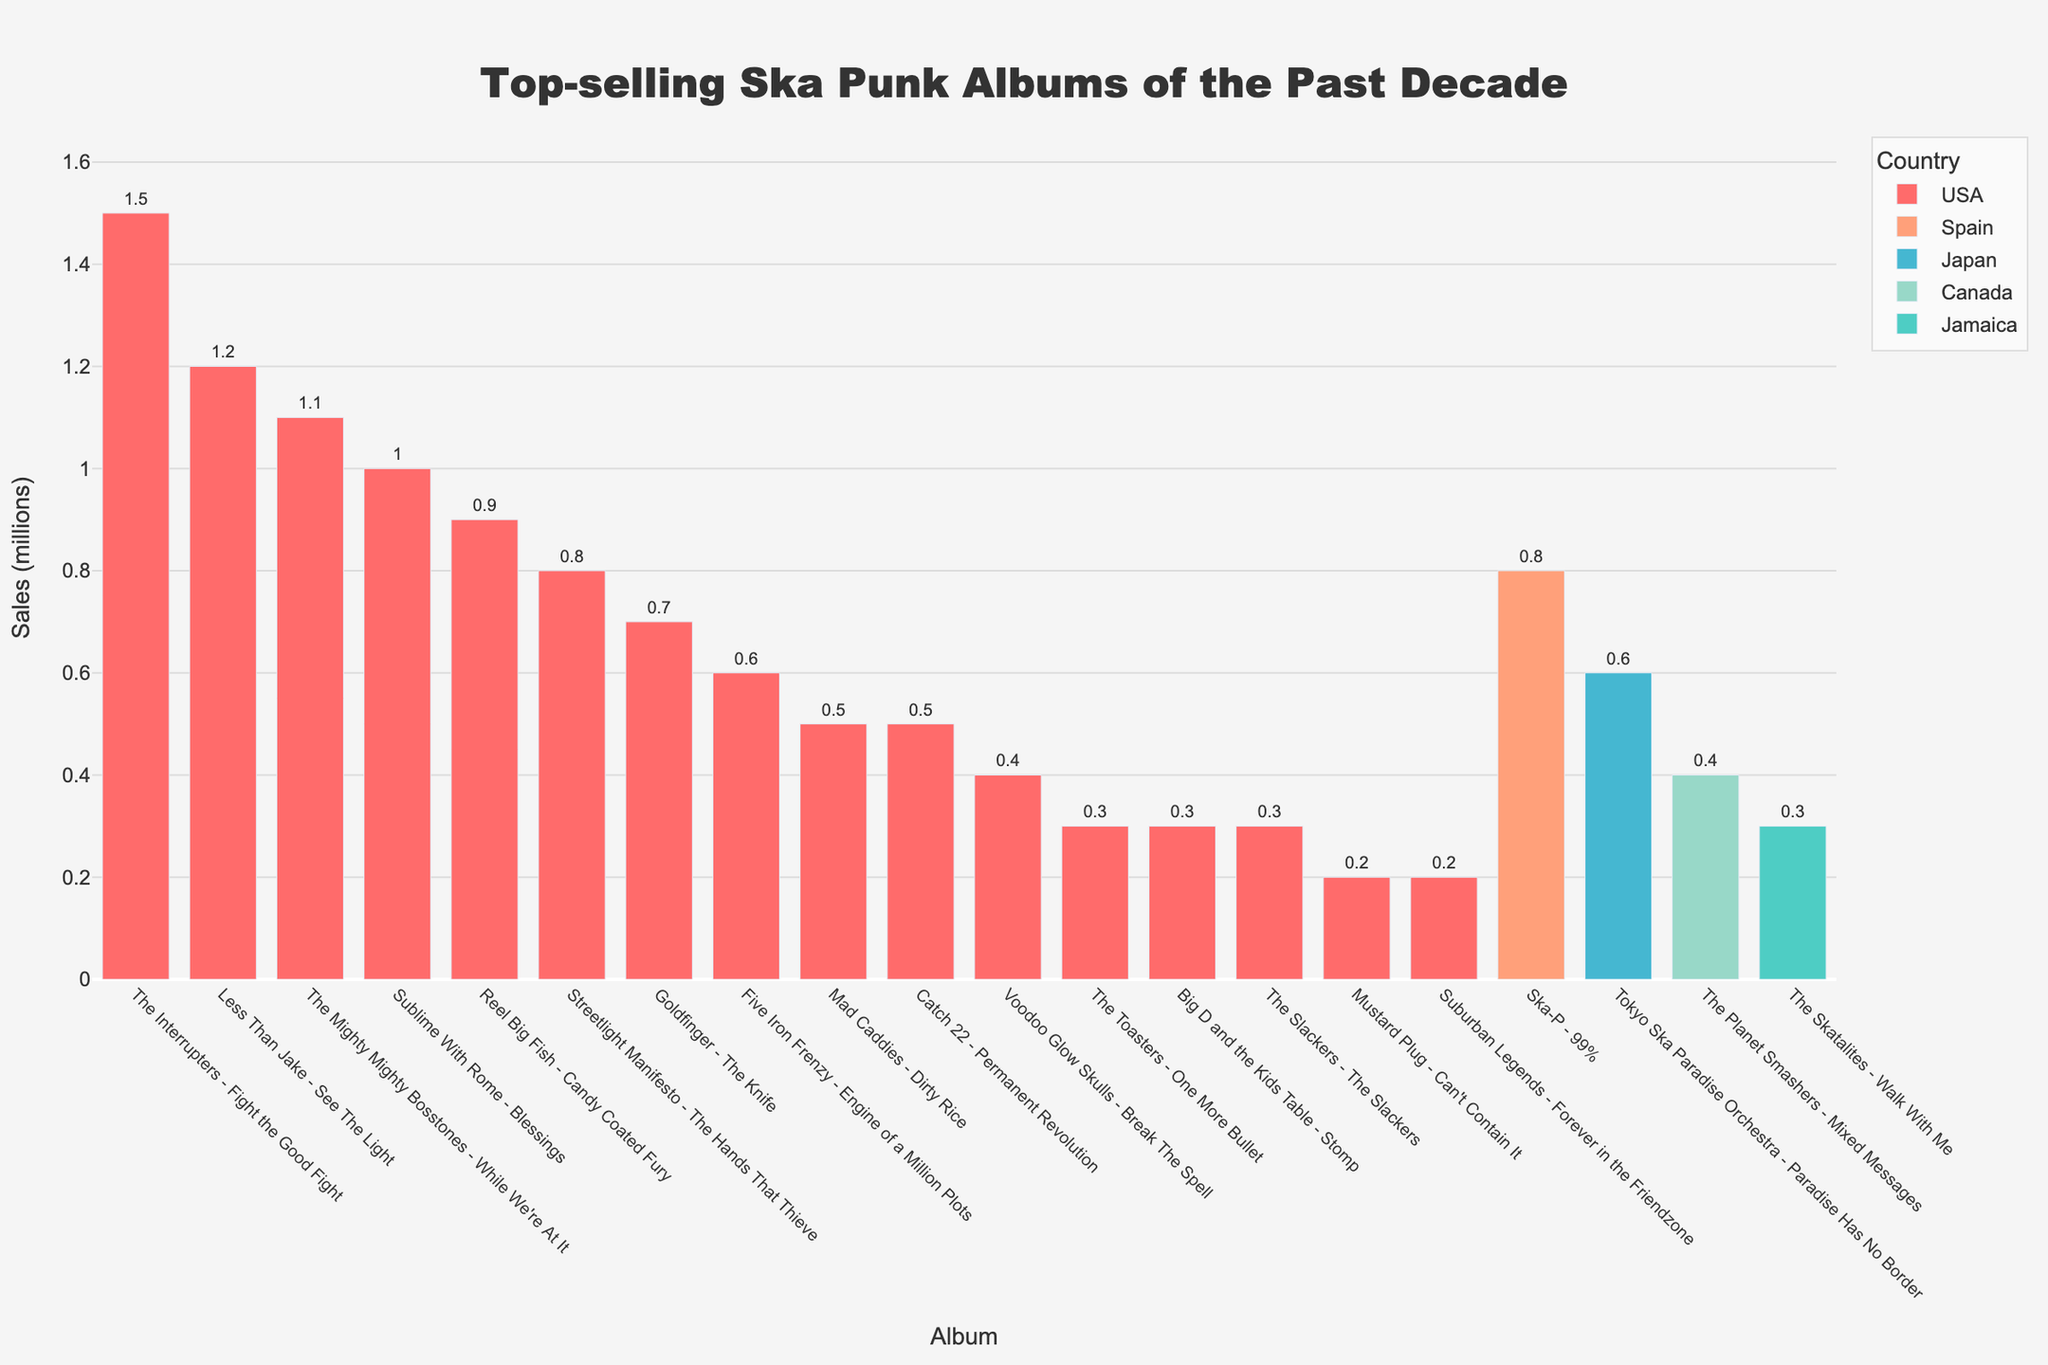Which album has the highest sales? The album with the highest bar represents the highest sales. The Interrupters - Fight the Good Fight has the tallest bar.
Answer: The Interrupters - Fight the Good Fight What is the combined sales of albums from Japan and Jamaica? Sum the sales of albums from Japan (0.6 million) and Jamaica (0.3 million). The sum is 0.6 + 0.3 = 0.9 million.
Answer: 0.9 million How does the sales of Mad Caddies - Dirty Rice compare to Big D and the Kids Table - Stomp? Compare the heights of the bars representing these albums. Dirty Rice has sales of 0.5 million, and Stomp has sales of 0.3 million. 0.5 million is greater than 0.3 million.
Answer: Dirty Rice has higher sales Which country has the most albums in the top-selling list? Count the bars for each country. The USA has the most bars.
Answer: USA Calculate the average sales of the albums from Spain and Canada. Sum the sales of albums from Spain (0.8 million) and Canada (0.4 million) and divide by the number of albums (1 each). (0.8 + 0.4) / 2 = 0.6 million.
Answer: 0.6 million What is the difference in sales between Less Than Jake - See The Light and The Mighty Mighty Bosstones - While We're At It? Subtract the sales of While We're At It (1.1 million) from See The Light (1.2 million). 1.2 - 1.1 = 0.1 million.
Answer: 0.1 million Which album has the smallest sales and from which country is it? Find the shortest bar, which represents Mustard Plug - Can't Contain It with sales of 0.2 million from the USA.
Answer: Mustard Plug - Can't Contain It, USA List the albums from the USA and their respective sales in descending order. Sort the bars representing USA albums by height in descending order: The Interrupters - Fight the Good Fight (1.5 million), Less Than Jake - See The Light (1.2 million), The Mighty Mighty Bosstones - While We're At It (1.1 million), Sublime With Rome - Blessings (1.0 million), Reel Big Fish - Candy Coated Fury (0.9 million), Streetlight Manifesto - The Hands That Thieve (0.8 million), Goldfinger - The Knife (0.7 million), Five Iron Frenzy - Engine of a Million Plots (0.6 million), The Slackers - The Slackers (0.3 million), The Toasters - One More Bullet (0.3 million), Big D and the Kids Table - Stomp (0.3 million), Voodoo Glow Skulls - Break The Spell (0.4 million), Catch 22 - Permanent Revolution (0.5 million), Mad Caddies - Dirty Rice (0.5 million), Suburban Legends - Forever in the Friendzone (0.2 million).
Answer: Various (see explanation) What is the sales range of the top-selling albums? Subtract the smallest sales (0.2 million) from the highest sales (1.5 million). 1.5 - 0.2 = 1.3 million.
Answer: 1.3 million How many albums sold over 1 million copies? Count the number of bars higher than the 1 million mark. Four albums sold over 1 million copies.
Answer: Four 